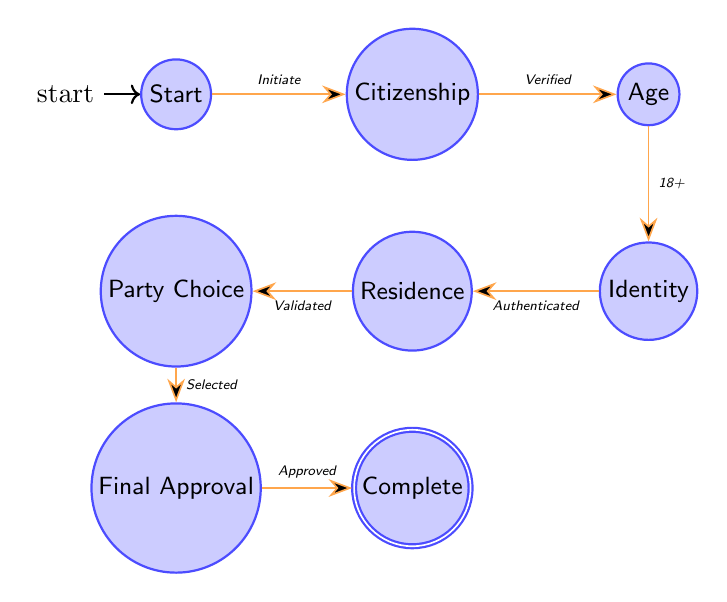What is the starting state of the voter registration process? The diagram indicates the starting state is labeled "Start." This is marked as the initial state where the process begins.
Answer: Start How many nodes are in the diagram? To find the total number of nodes, we can count each state listed: Start, Citizenship, Age, Identity, Residence, Party Choice, Final Approval, and Complete. This totals to eight nodes in the diagram.
Answer: 8 What follows after Citizenship Verification? The transition from the "CitizenshipVerification" state leads directly to the "AgeVerification" state when the citizenship is verified, as indicated by the arrow connecting these two states.
Answer: Age Verification What is the final state of the voter registration process? The final state, as indicated in the diagram, is "RegistrationComplete." This represents the end of the voter registration process after all previous verifications and approval have been completed.
Answer: Registration Complete Which state allows the applicant to choose a political party? The state where the applicant is allowed to choose a political party is "PoliticalPartyChoice," as indicated by the transition from the "ResidenceVerification" state leading to it.
Answer: Political Party Choice What is the transition from Identity Verification to the next state? The transition from the "IdentityVerification" state proceeds to "ResidenceVerification." This indicates that after verifying identity, the next step is to validate residential status.
Answer: Residence Verification What is required for the transition from Political Party Choice to Final Approval? The transition from "PoliticalPartyChoice" to "FinalApproval" occurs after the political party has been selected by the applicant, as noted in the transition description.
Answer: Selected How many transitions are there in total? To determine the total number of transitions in the diagram, we can count the arrows between the states, which total to seven transitions connecting the eight states.
Answer: 7 